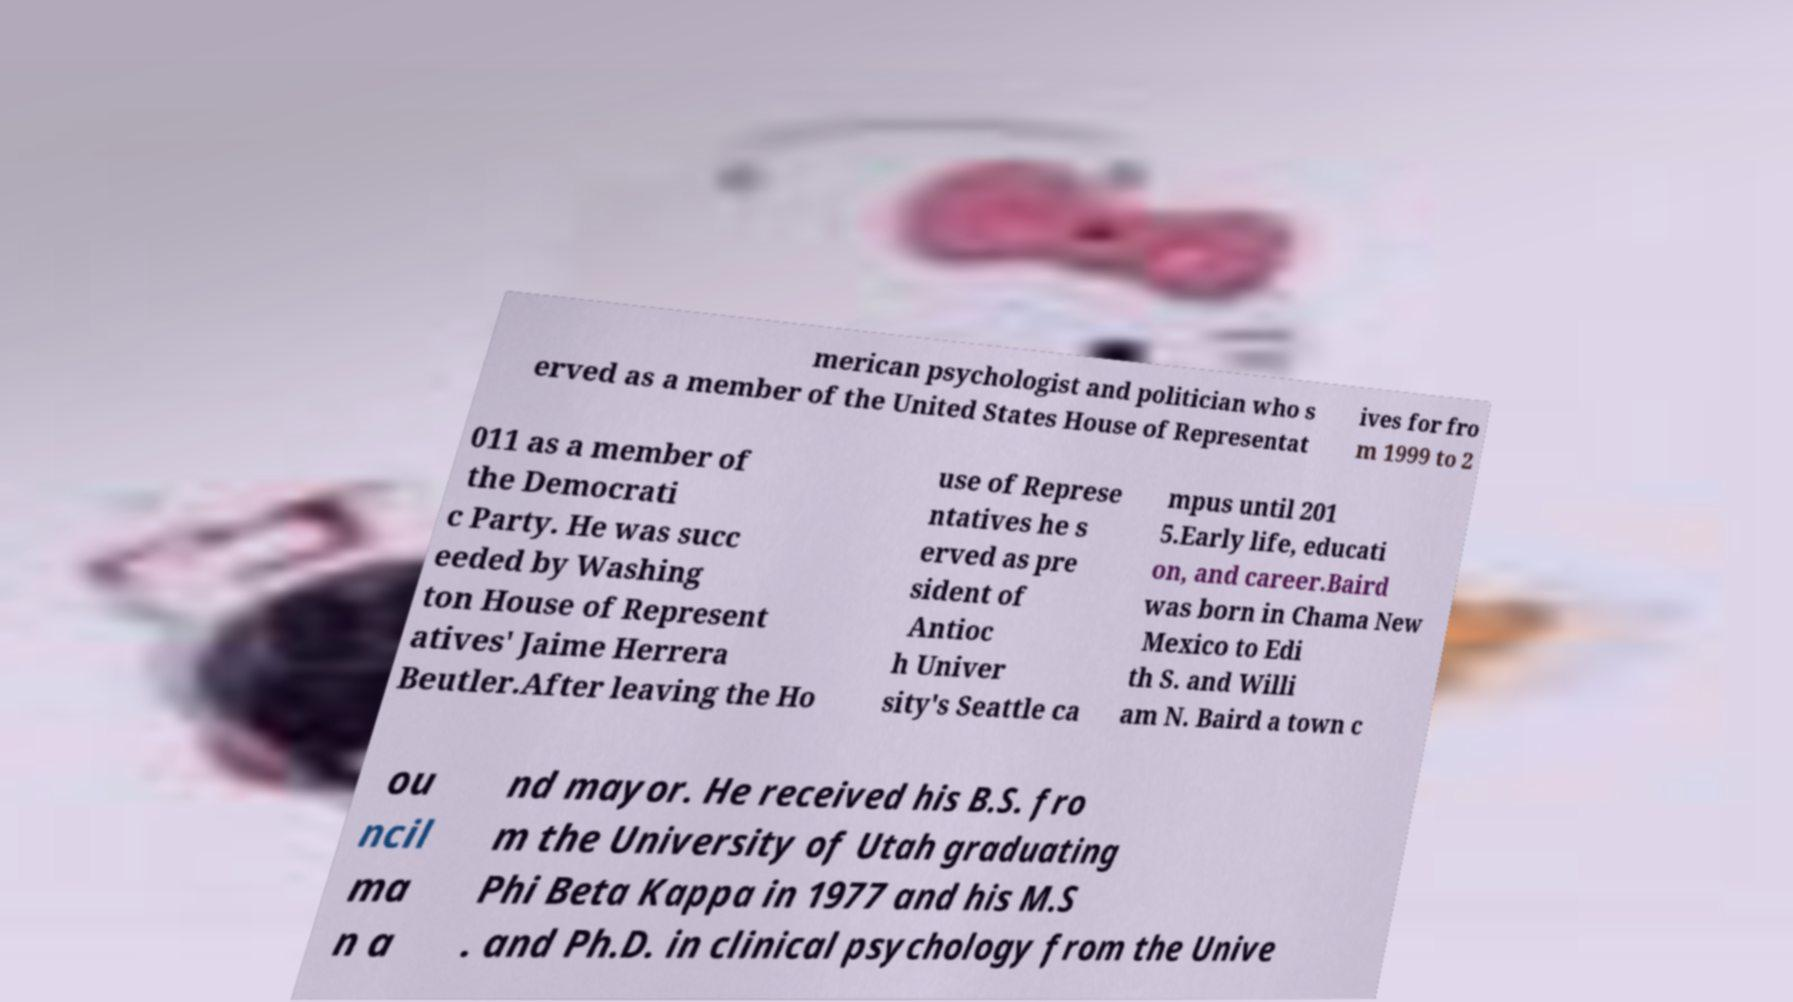Could you assist in decoding the text presented in this image and type it out clearly? merican psychologist and politician who s erved as a member of the United States House of Representat ives for fro m 1999 to 2 011 as a member of the Democrati c Party. He was succ eeded by Washing ton House of Represent atives' Jaime Herrera Beutler.After leaving the Ho use of Represe ntatives he s erved as pre sident of Antioc h Univer sity's Seattle ca mpus until 201 5.Early life, educati on, and career.Baird was born in Chama New Mexico to Edi th S. and Willi am N. Baird a town c ou ncil ma n a nd mayor. He received his B.S. fro m the University of Utah graduating Phi Beta Kappa in 1977 and his M.S . and Ph.D. in clinical psychology from the Unive 